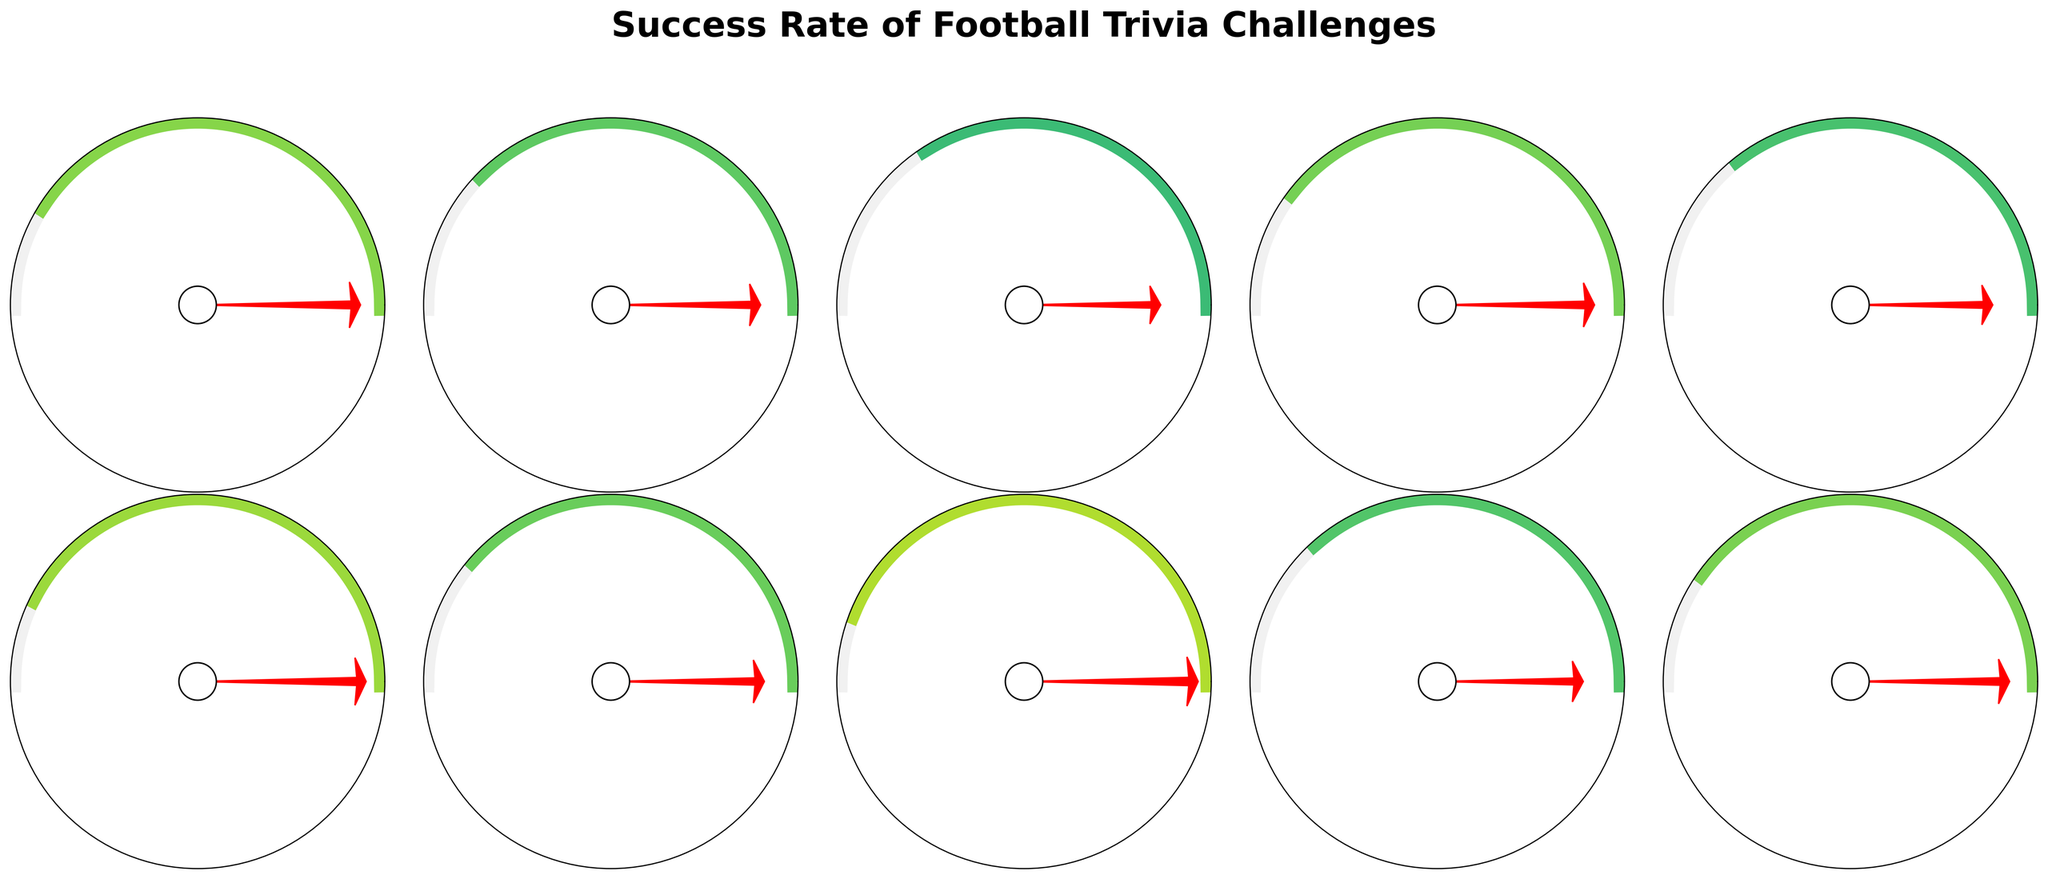What's the success rate for identifying top goalscorers? Look at the segment labeled "Top Goalscorers Identification" and read the percentage value indicated within it.
Answer: 88% Which trivia category has the highest success rate? Compare the success rate percentages for all categories and identify the highest value, observing the corresponding category.
Answer: Historical Match Results What is the average success rate for all football trivia categories? Sum up all the success rates (82 + 75 + 68 + 79 + 71 + 85 + 77 + 88 + 73 + 80) and divide by the total number of categories (10).
Answer: 77.8% Are there more categories above or below an 80% success rate? Count the number of categories with success rates higher than 80% (Premier League Trivia, Historical Match Results, Top Goalscorers Identification, Famous Managers Recognition) and those below it.
Answer: Below Which categories have a success rate closest to 75%? Identify categories with success rates near 75% by comparing all values. "World Cup History" is 75% and "Football Rules and Regulations" is 73%.
Answer: World Cup History, Football Rules and Regulations What is the difference in success rate between the categories "Player Transfer Records" and "European Leagues Knowledge"? Subtract the success rate of "European Leagues Knowledge" from "Player Transfer Records" (79% - 68%).
Answer: 11% How many categories have a success rate greater than 70%? Count all categories where the success rate is higher than 70% (Premier League Trivia, World Cup History, Player Transfer Records, Football Tactics Understanding, Historical Match Results, Football Club Origins, Top Goalscorers Identification, Football Rules and Regulations, Famous Managers Recognition).
Answer: 9 Which categories have a success rate between 70% and 80%? Identify categories within the given range (71%, 73%, 75%, 77%, 79%, 80%).
Answer: World Cup History, Football Tactics Understanding, Football Club Origins, Player Transfer Records, Famous Managers Recognition, Football Rules and Regulations What is the sum of the success rates for "Premier League Trivia" and "Historical Match Results"? Add the success rates of "Premier League Trivia" and "Historical Match Results" (82% + 85%).
Answer: 167% 